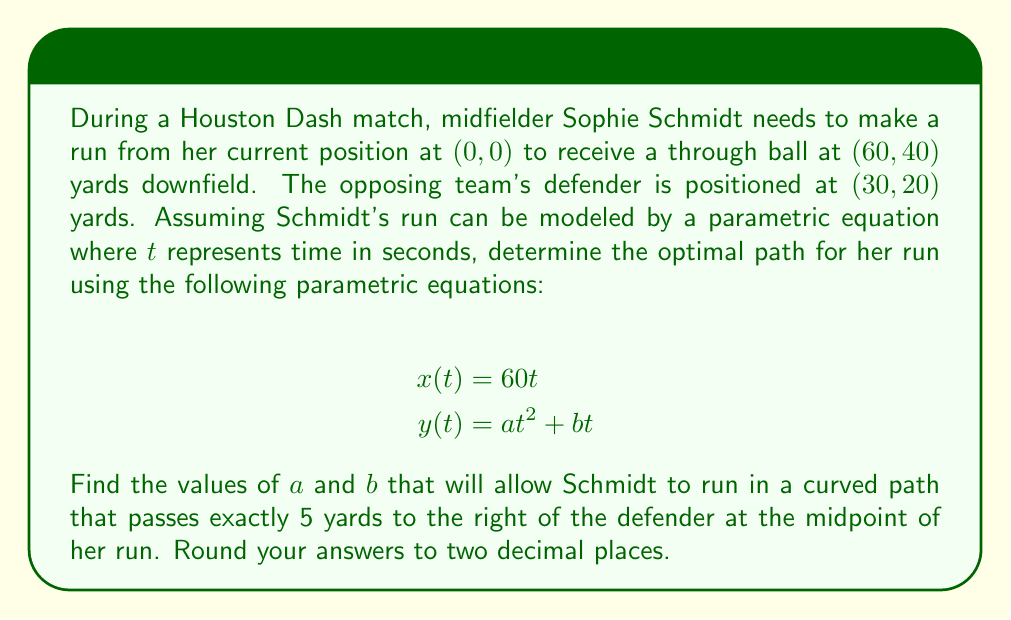Solve this math problem. Let's approach this step-by-step:

1) First, we know that Schmidt's run starts at (0, 0) and ends at (60, 40). This means:
   At $t = 0$: $x(0) = 0$, $y(0) = 0$
   At $t = 1$: $x(1) = 60$, $y(1) = 40$

2) The midpoint of her run occurs at $t = 0.5$. At this point, she should be 5 yards to the right of the defender.

3) At $t = 0.5$:
   $x(0.5) = 60(0.5) = 30$
   $y(0.5) = a(0.5)^2 + b(0.5)$

4) The point 5 yards to the right of the defender is (35, 20). So:
   $30 = 35$ (this is already satisfied)
   $a(0.5)^2 + b(0.5) = 20$

5) We also know that at $t = 1$:
   $a(1)^2 + b(1) = 40$

6) Now we have two equations:
   $0.25a + 0.5b = 20$
   $a + b = 40$

7) Multiply the first equation by 4:
   $a + 2b = 80$
   $a + b = 40$

8) Subtracting the second equation from the first:
   $b = 40$

9) Substituting this back into $a + b = 40$:
   $a + 40 = 40$
   $a = 0$

Therefore, the optimal path is described by:
$$x(t) = 60t$$
$$y(t) = 40t$$
Answer: $a = 0.00$, $b = 40.00$ 